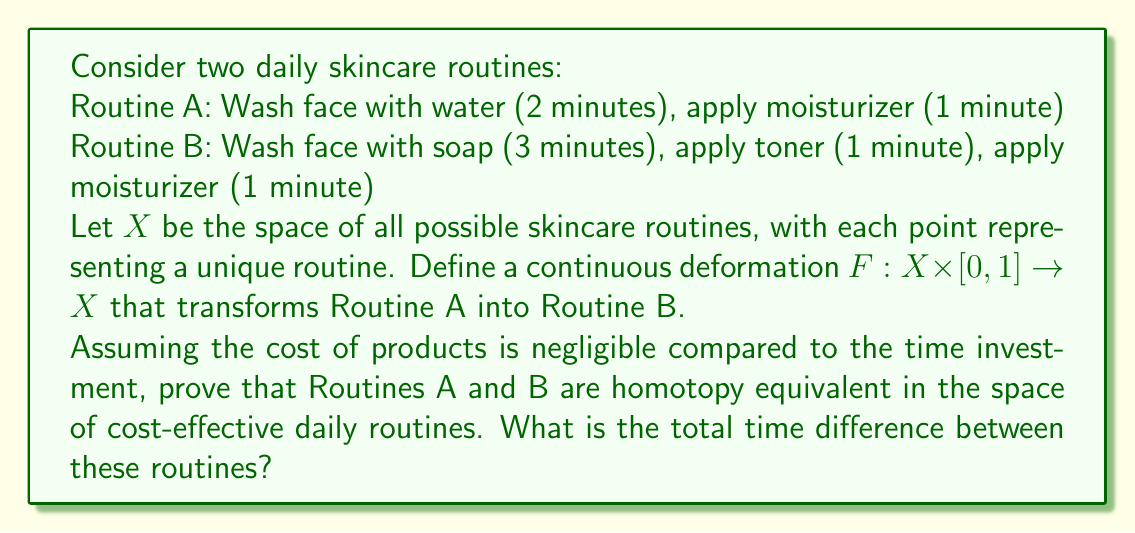Show me your answer to this math problem. To prove that Routines A and B are homotopy equivalent, we need to show that there exists a continuous deformation between them in the space of cost-effective daily routines.

Let's define the homotopy $F: X \times [0,1] \rightarrow X$ as follows:

For $t \in [0,1]$:

1. Washing step: $(2+t)$ minutes
2. Toner step: $t$ minutes
3. Moisturizer step: $1$ minute

At $t=0$, we have Routine A:
$F(x,0) = (2,0,1)$ minutes

At $t=1$, we have Routine B:
$F(x,1) = (3,1,1)$ minutes

This homotopy continuously deforms Routine A into Routine B within the space of cost-effective routines. The deformation is continuous because the time for each step changes linearly with $t$.

To show that this homotopy preserves cost-effectiveness, we need to consider the total time of each routine:

Routine A total time: $2 + 0 + 1 = 3$ minutes
Routine B total time: $3 + 1 + 1 = 5$ minutes

The difference in total time is minimal (2 minutes), and both routines are relatively quick, fitting the persona of someone who considers extensive skincare routines as extravagant.

The homotopy equivalence implies that, from a topological perspective, these routines are essentially the same in the space of cost-effective daily routines. This aligns with the persona's view that simple, time-efficient routines are preferred.

To calculate the total time difference:

$$\text{Time difference} = \text{Time(Routine B)} - \text{Time(Routine A)} = 5 - 3 = 2 \text{ minutes}$$
Answer: Routines A and B are homotopy equivalent in the space of cost-effective daily routines. The total time difference between these routines is 2 minutes. 